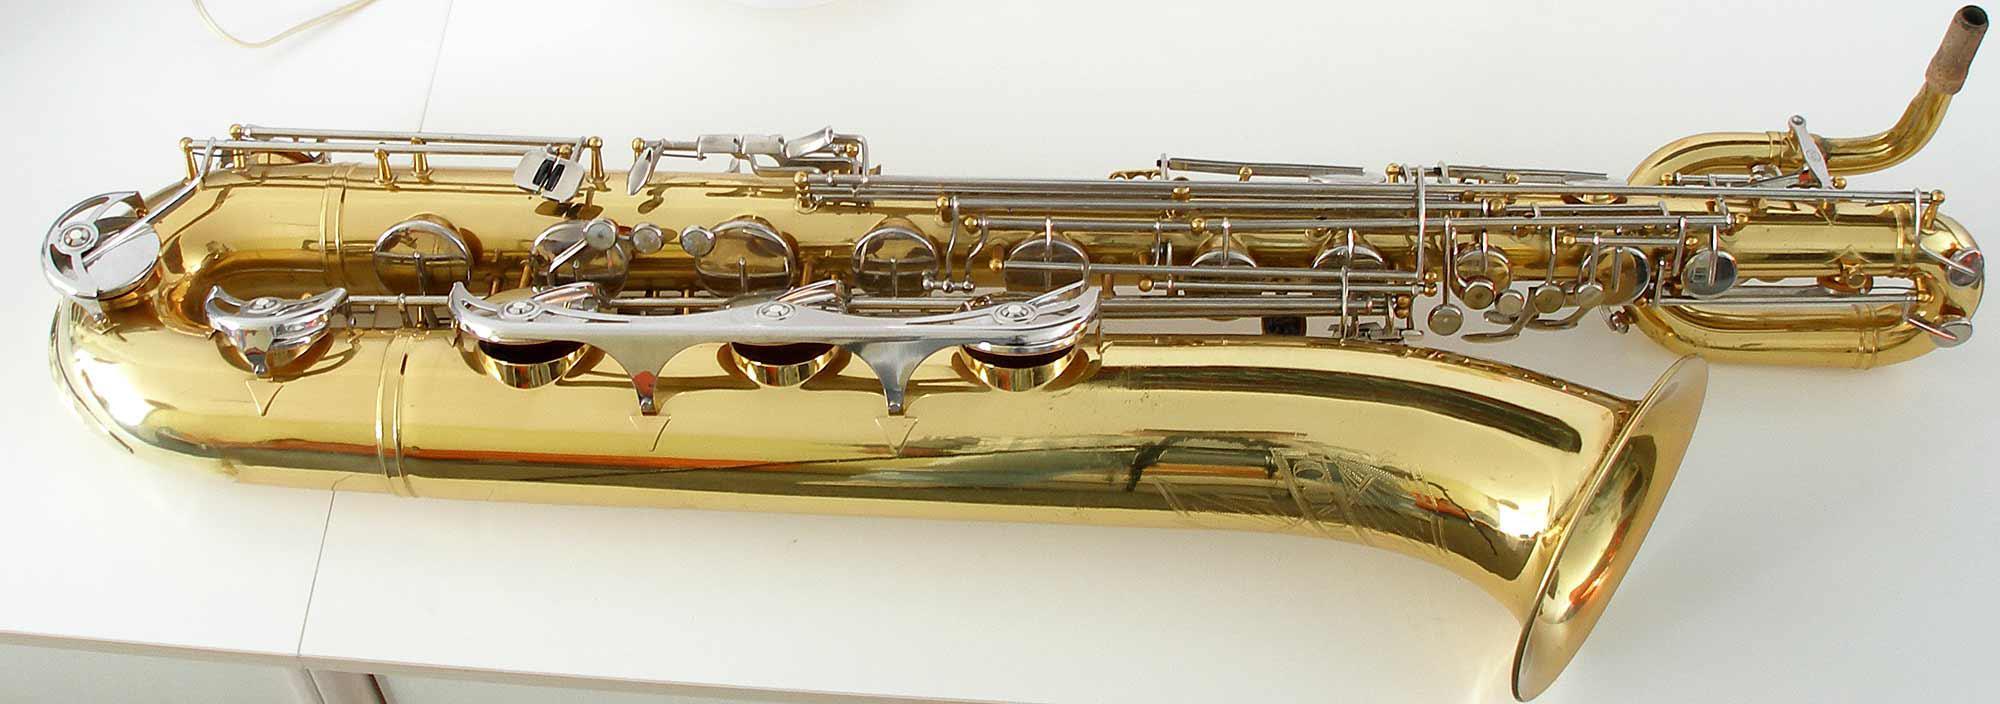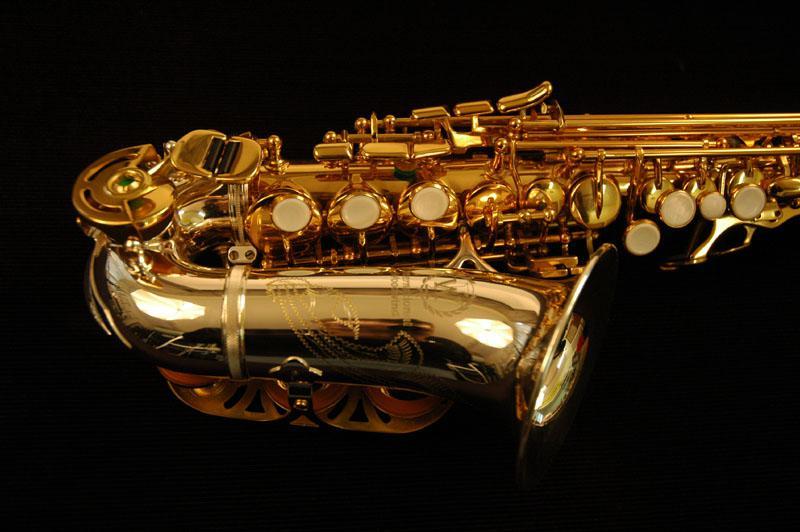The first image is the image on the left, the second image is the image on the right. Considering the images on both sides, is "The bell ends of two saxophones in different colors are lying horizontally, pointed toward the same direction." valid? Answer yes or no. Yes. The first image is the image on the left, the second image is the image on the right. Assess this claim about the two images: "Both saxophones are positioned with their bells to the right.". Correct or not? Answer yes or no. Yes. 